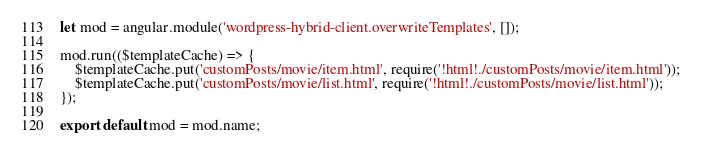<code> <loc_0><loc_0><loc_500><loc_500><_JavaScript_>let mod = angular.module('wordpress-hybrid-client.overwriteTemplates', []);

mod.run(($templateCache) => {
    $templateCache.put('customPosts/movie/item.html', require('!html!./customPosts/movie/item.html'));
    $templateCache.put('customPosts/movie/list.html', require('!html!./customPosts/movie/list.html'));
});

export default mod = mod.name;
</code> 